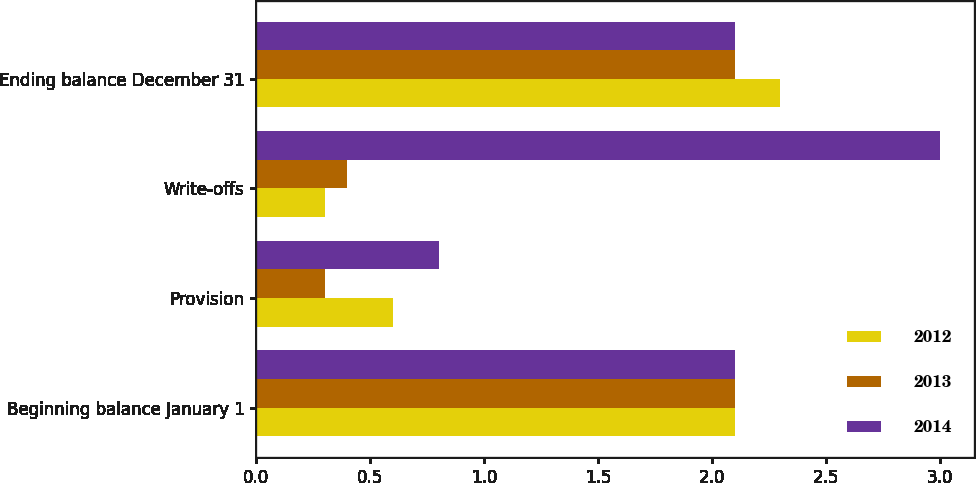Convert chart to OTSL. <chart><loc_0><loc_0><loc_500><loc_500><stacked_bar_chart><ecel><fcel>Beginning balance January 1<fcel>Provision<fcel>Write-offs<fcel>Ending balance December 31<nl><fcel>2012<fcel>2.1<fcel>0.6<fcel>0.3<fcel>2.3<nl><fcel>2013<fcel>2.1<fcel>0.3<fcel>0.4<fcel>2.1<nl><fcel>2014<fcel>2.1<fcel>0.8<fcel>3<fcel>2.1<nl></chart> 